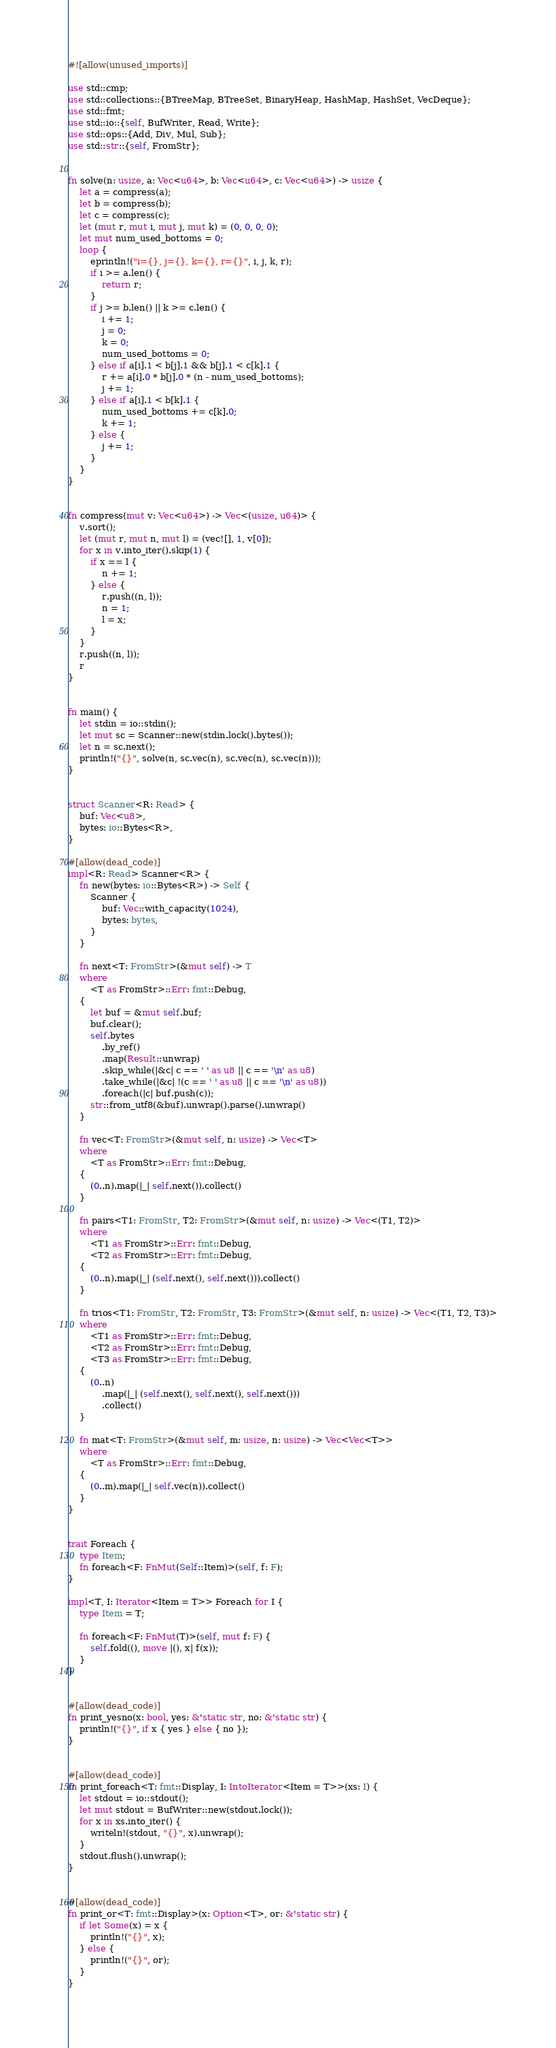Convert code to text. <code><loc_0><loc_0><loc_500><loc_500><_Rust_>#![allow(unused_imports)]

use std::cmp;
use std::collections::{BTreeMap, BTreeSet, BinaryHeap, HashMap, HashSet, VecDeque};
use std::fmt;
use std::io::{self, BufWriter, Read, Write};
use std::ops::{Add, Div, Mul, Sub};
use std::str::{self, FromStr};


fn solve(n: usize, a: Vec<u64>, b: Vec<u64>, c: Vec<u64>) -> usize {
    let a = compress(a);
    let b = compress(b);
    let c = compress(c);
    let (mut r, mut i, mut j, mut k) = (0, 0, 0, 0);
    let mut num_used_bottoms = 0;
    loop {
        eprintln!("i={}, j={}, k={}, r={}", i, j, k, r);
        if i >= a.len() {
            return r;
        }
        if j >= b.len() || k >= c.len() {
            i += 1;
            j = 0;
            k = 0;
            num_used_bottoms = 0;
        } else if a[i].1 < b[j].1 && b[j].1 < c[k].1 {
            r += a[i].0 * b[j].0 * (n - num_used_bottoms);
            j += 1;
        } else if a[i].1 < b[k].1 {
            num_used_bottoms += c[k].0;
            k += 1;
        } else {
            j += 1;
        }
    }
}


fn compress(mut v: Vec<u64>) -> Vec<(usize, u64)> {
    v.sort();
    let (mut r, mut n, mut l) = (vec![], 1, v[0]);
    for x in v.into_iter().skip(1) {
        if x == l {
            n += 1;
        } else {
            r.push((n, l));
            n = 1;
            l = x;
        }
    }
    r.push((n, l));
    r
}


fn main() {
    let stdin = io::stdin();
    let mut sc = Scanner::new(stdin.lock().bytes());
    let n = sc.next();
    println!("{}", solve(n, sc.vec(n), sc.vec(n), sc.vec(n)));
}


struct Scanner<R: Read> {
    buf: Vec<u8>,
    bytes: io::Bytes<R>,
}

#[allow(dead_code)]
impl<R: Read> Scanner<R> {
    fn new(bytes: io::Bytes<R>) -> Self {
        Scanner {
            buf: Vec::with_capacity(1024),
            bytes: bytes,
        }
    }

    fn next<T: FromStr>(&mut self) -> T
    where
        <T as FromStr>::Err: fmt::Debug,
    {
        let buf = &mut self.buf;
        buf.clear();
        self.bytes
            .by_ref()
            .map(Result::unwrap)
            .skip_while(|&c| c == ' ' as u8 || c == '\n' as u8)
            .take_while(|&c| !(c == ' ' as u8 || c == '\n' as u8))
            .foreach(|c| buf.push(c));
        str::from_utf8(&buf).unwrap().parse().unwrap()
    }

    fn vec<T: FromStr>(&mut self, n: usize) -> Vec<T>
    where
        <T as FromStr>::Err: fmt::Debug,
    {
        (0..n).map(|_| self.next()).collect()
    }

    fn pairs<T1: FromStr, T2: FromStr>(&mut self, n: usize) -> Vec<(T1, T2)>
    where
        <T1 as FromStr>::Err: fmt::Debug,
        <T2 as FromStr>::Err: fmt::Debug,
    {
        (0..n).map(|_| (self.next(), self.next())).collect()
    }

    fn trios<T1: FromStr, T2: FromStr, T3: FromStr>(&mut self, n: usize) -> Vec<(T1, T2, T3)>
    where
        <T1 as FromStr>::Err: fmt::Debug,
        <T2 as FromStr>::Err: fmt::Debug,
        <T3 as FromStr>::Err: fmt::Debug,
    {
        (0..n)
            .map(|_| (self.next(), self.next(), self.next()))
            .collect()
    }

    fn mat<T: FromStr>(&mut self, m: usize, n: usize) -> Vec<Vec<T>>
    where
        <T as FromStr>::Err: fmt::Debug,
    {
        (0..m).map(|_| self.vec(n)).collect()
    }
}


trait Foreach {
    type Item;
    fn foreach<F: FnMut(Self::Item)>(self, f: F);
}

impl<T, I: Iterator<Item = T>> Foreach for I {
    type Item = T;

    fn foreach<F: FnMut(T)>(self, mut f: F) {
        self.fold((), move |(), x| f(x));
    }
}


#[allow(dead_code)]
fn print_yesno(x: bool, yes: &'static str, no: &'static str) {
    println!("{}", if x { yes } else { no });
}


#[allow(dead_code)]
fn print_foreach<T: fmt::Display, I: IntoIterator<Item = T>>(xs: I) {
    let stdout = io::stdout();
    let mut stdout = BufWriter::new(stdout.lock());
    for x in xs.into_iter() {
        writeln!(stdout, "{}", x).unwrap();
    }
    stdout.flush().unwrap();
}


#[allow(dead_code)]
fn print_or<T: fmt::Display>(x: Option<T>, or: &'static str) {
    if let Some(x) = x {
        println!("{}", x);
    } else {
        println!("{}", or);
    }
}
</code> 